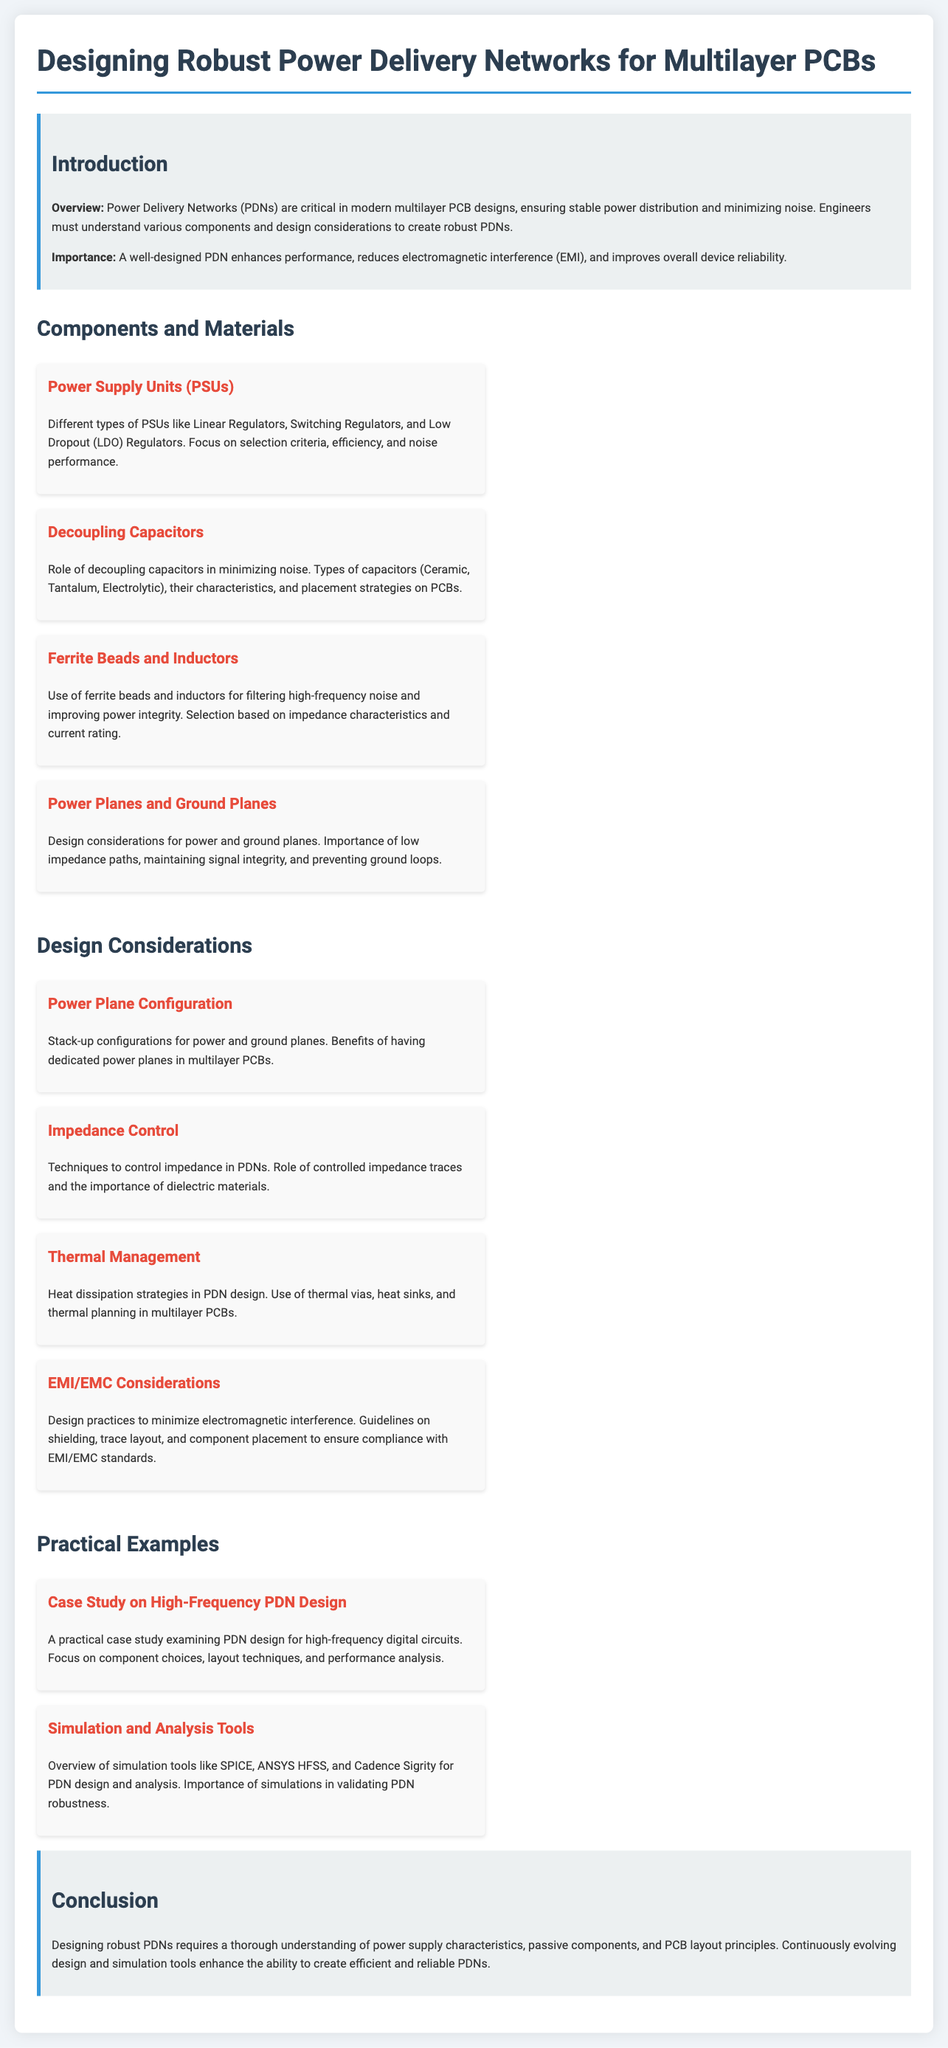What is the importance of PDNs? The importance of PDNs is highlighted as enhancing performance, reducing electromagnetic interference (EMI), and improving overall device reliability.
Answer: Enhances performance What type of capacitors are mentioned for decoupling? The document mentions Ceramic, Tantalum, and Electrolytic as types of capacitors used for decoupling.
Answer: Ceramic, Tantalum, Electrolytic What does the section on thermal management discuss? The section on thermal management discusses heat dissipation strategies in PDN design, including thermal vias, heat sinks, and thermal planning in multilayer PCBs.
Answer: Heat dissipation strategies What is a key technique for controlling impedance in PDNs? A key technique for controlling impedance mentioned in the document is the use of controlled impedance traces.
Answer: Controlled impedance traces What is an example of a simulation tool for PDN design? The document mentions SPICE as one of the simulation tools for PDN design and analysis.
Answer: SPICE How do ferrite beads and inductors contribute to PDNs? Ferrite beads and inductors are used for filtering high-frequency noise and improving power integrity in PDNs.
Answer: Filtering high-frequency noise What design consideration minimizes electromagnetic interference? The design practices focused on shielding, trace layout, and component placement minimize electromagnetic interference.
Answer: Shielding What does "Case Study on High-Frequency PDN Design" focus on? This case study focuses on component choices, layout techniques, and performance analysis for high-frequency digital circuits.
Answer: Component choices, layout techniques, and performance analysis 